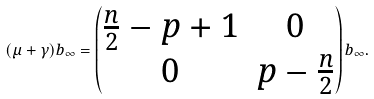Convert formula to latex. <formula><loc_0><loc_0><loc_500><loc_500>( \mu + \gamma ) b _ { \infty } = \begin{pmatrix} \frac { n } { 2 } - p + 1 & 0 \\ 0 & p - \frac { n } { 2 } \end{pmatrix} b _ { \infty } .</formula> 